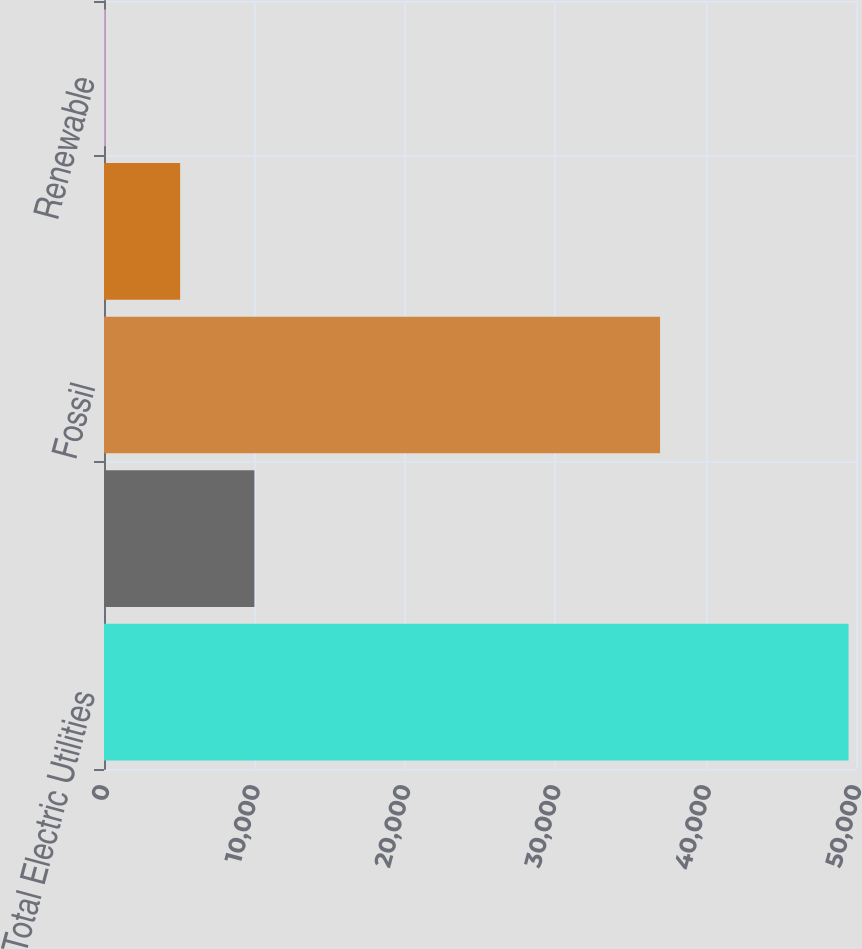Convert chart. <chart><loc_0><loc_0><loc_500><loc_500><bar_chart><fcel>Total Electric Utilities<fcel>Nuclear<fcel>Fossil<fcel>Hydro<fcel>Renewable<nl><fcel>49506<fcel>9999.6<fcel>36972<fcel>5061.3<fcel>123<nl></chart> 